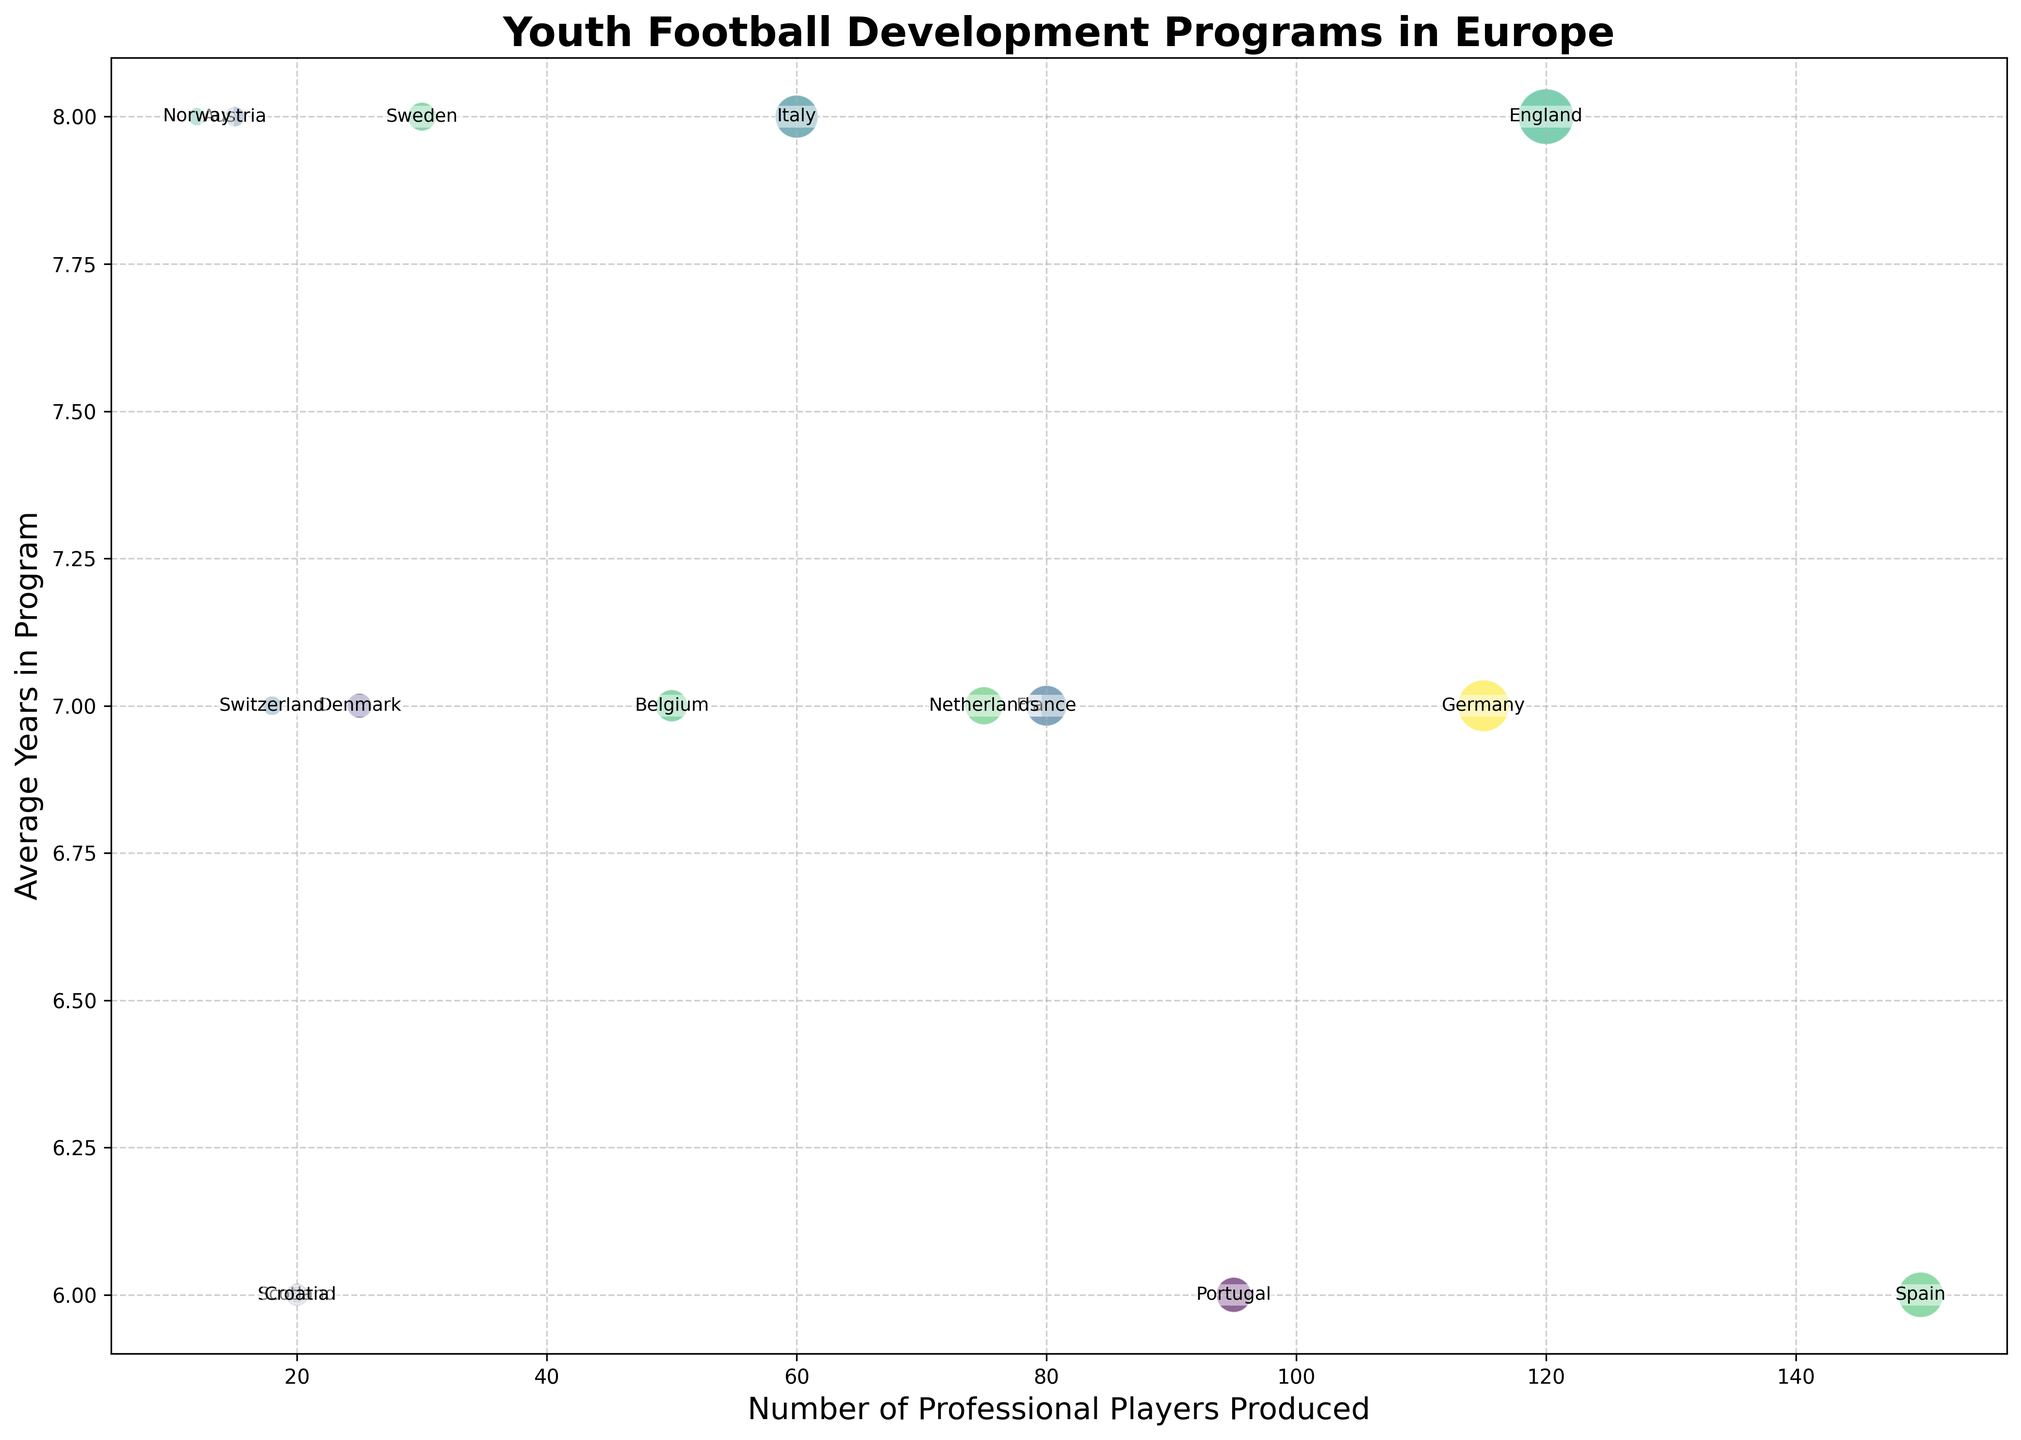What is the relationship between the number of professional players produced and the average years in the program for Spain? The bubble representing Spain (La Masia) lies on the x-axis at 150 (professional players produced) and on the y-axis at 6 (average years in the program). This indicates that La Masia produces 150 professional players with an average of 6 years in the program.
Answer: La Masia produces 150 professional players with 6 years in the program Which country has the highest number of professional players produced and what is the average years in their program? The bubble for Spain (La Masia) is located furthest to the right on the x-axis, indicating the highest number of professional players produced (150). Its position on the y-axis is at 6, indicating the average years in the program.
Answer: Spain, 6 years Compare Germany and France in terms of average years in the program and the number of professional players produced. Germany (DFB-Junioren) has 115 professional players produced and an average of 7 years in the program, whereas France (Clairefontaine) has 80 professional players produced and also averages 7 years in the program. Germany produces more professional players and has the same average years in the program as France.
Answer: Germany produces more players; both have 7 years in the program Which country has the smallest bubble, and what does it represent in terms of participants? The bubble for Croatia (HNS Academy) is the smallest. It represents the number of participants, which is 1,500 – the smallest among all bubbles on the chart.
Answer: Croatia, 1,500 participants Identify the country with a program that has an average of 8 years and how many professional players it produces. By looking at the y-axis at 8 years, the bubbles representing England, Italy, Austria, Sweden, and Norway are positioned there. Among these, England (FA Youth Development) produces 120 professional players, Italy (FIGC Academies) produces 60, Austria (ÖFB Akademie) produces 15, Sweden (Svenska Fotbollförbundet Program) produces 30, and Norway (NFF Talentprogram) produces 12.
Answer: England produces 120 players, Italy 60, Austria 15, Sweden 30, and Norway 12 